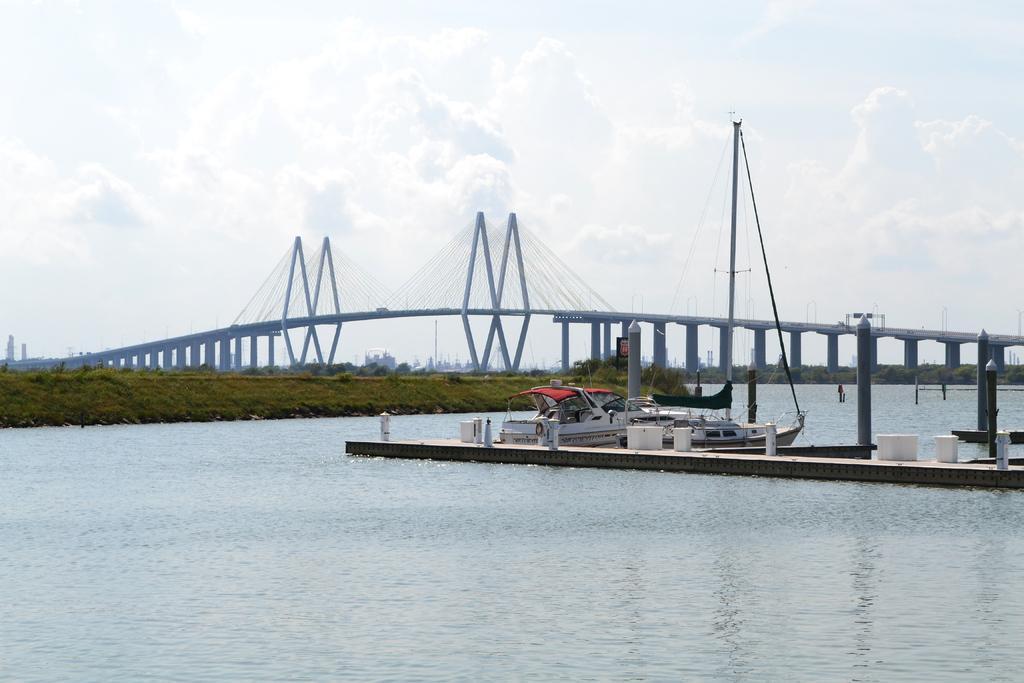Please provide a concise description of this image. In the foreground of this image, there is water and a dock. Behind it, there is a boat on the water. In the background, there is grassland, a bridge and the sky. 